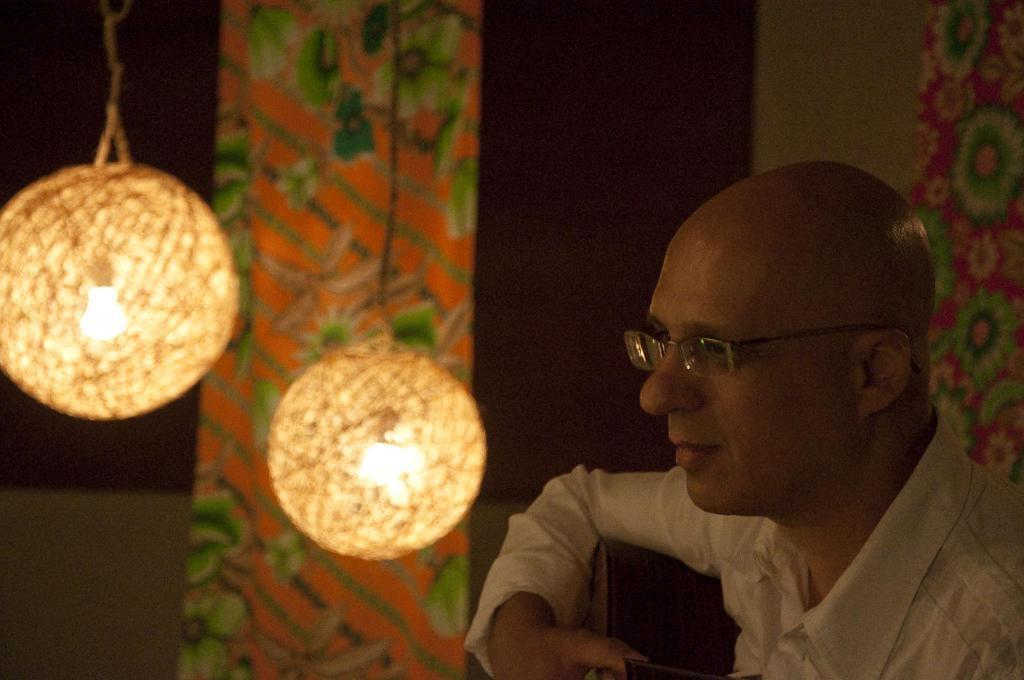How would you summarize this image in a sentence or two? In this image I can see a man is wearing spectacles. Here I can see lights. 